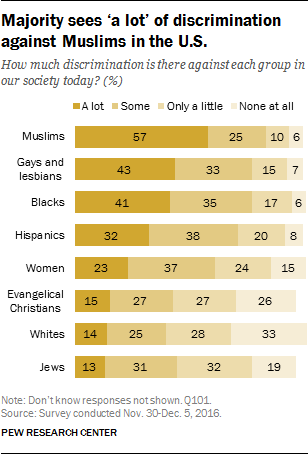Mention a couple of crucial points in this snapshot. Of the bars that have a value of 27, how many have a value of 27? The value of the opinion "A lot" is significant for Muslims. 